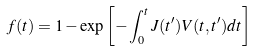<formula> <loc_0><loc_0><loc_500><loc_500>f ( t ) = 1 - \exp \left [ - \int _ { 0 } ^ { t } J ( t ^ { \prime } ) V ( t , t ^ { \prime } ) d t \right ]</formula> 